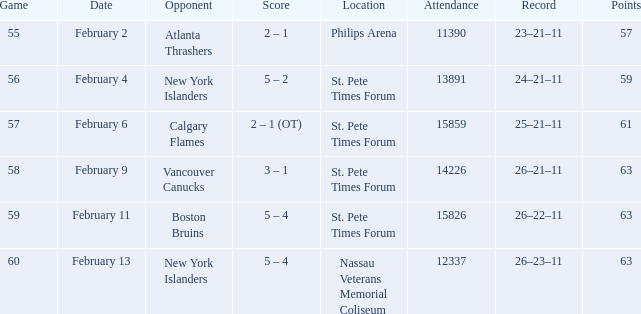What scores happened on February 11? 5 – 4. 